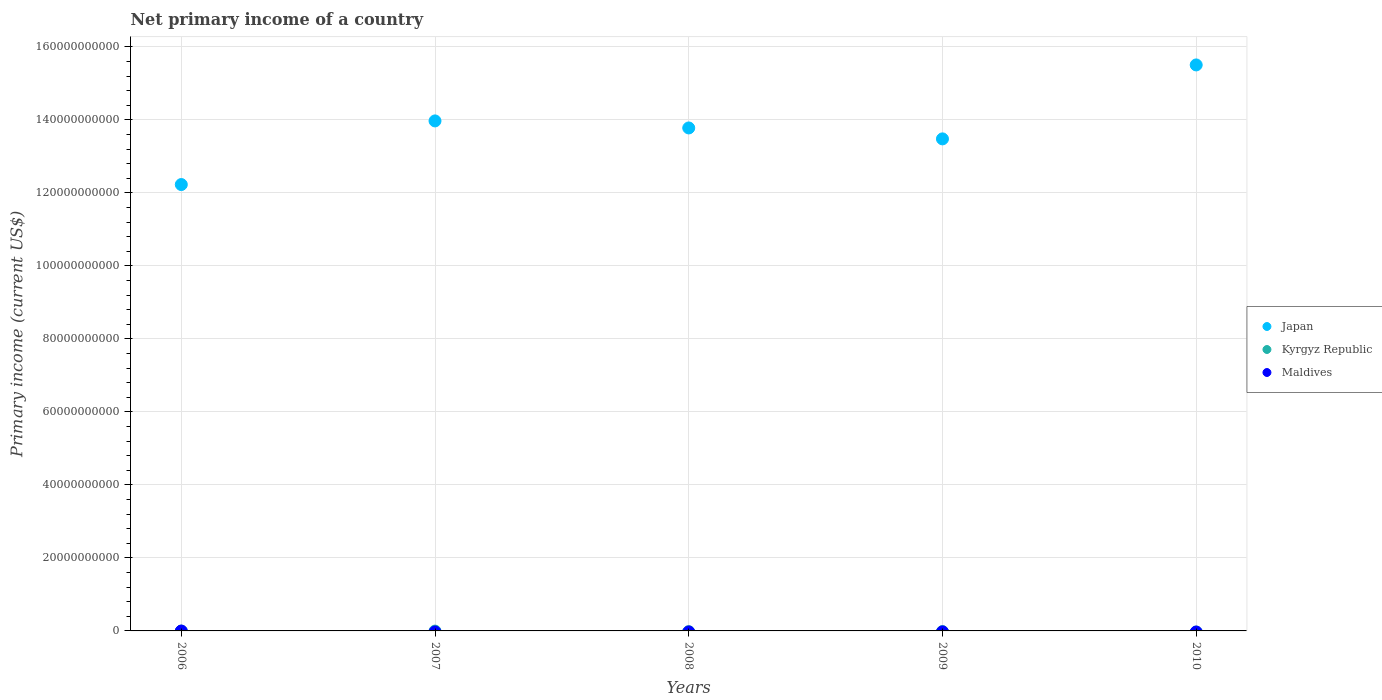Is the number of dotlines equal to the number of legend labels?
Your answer should be very brief. No. Across all years, what is the maximum primary income in Japan?
Ensure brevity in your answer.  1.55e+11. Across all years, what is the minimum primary income in Japan?
Ensure brevity in your answer.  1.22e+11. In which year was the primary income in Japan maximum?
Ensure brevity in your answer.  2010. What is the total primary income in Maldives in the graph?
Offer a terse response. 0. What is the difference between the primary income in Japan in 2008 and that in 2010?
Offer a very short reply. -1.73e+1. What is the difference between the primary income in Kyrgyz Republic in 2006 and the primary income in Japan in 2007?
Your answer should be compact. -1.40e+11. What is the ratio of the primary income in Japan in 2007 to that in 2010?
Ensure brevity in your answer.  0.9. What is the difference between the highest and the second highest primary income in Japan?
Provide a short and direct response. 1.53e+1. What is the difference between the highest and the lowest primary income in Japan?
Provide a succinct answer. 3.28e+1. In how many years, is the primary income in Maldives greater than the average primary income in Maldives taken over all years?
Your answer should be very brief. 0. Does the primary income in Japan monotonically increase over the years?
Keep it short and to the point. No. Is the primary income in Maldives strictly greater than the primary income in Kyrgyz Republic over the years?
Offer a terse response. No. What is the difference between two consecutive major ticks on the Y-axis?
Make the answer very short. 2.00e+1. Does the graph contain any zero values?
Offer a terse response. Yes. Where does the legend appear in the graph?
Provide a succinct answer. Center right. How many legend labels are there?
Provide a succinct answer. 3. How are the legend labels stacked?
Offer a very short reply. Vertical. What is the title of the graph?
Offer a very short reply. Net primary income of a country. Does "Greece" appear as one of the legend labels in the graph?
Provide a succinct answer. No. What is the label or title of the X-axis?
Keep it short and to the point. Years. What is the label or title of the Y-axis?
Make the answer very short. Primary income (current US$). What is the Primary income (current US$) in Japan in 2006?
Your answer should be very brief. 1.22e+11. What is the Primary income (current US$) in Maldives in 2006?
Make the answer very short. 0. What is the Primary income (current US$) of Japan in 2007?
Make the answer very short. 1.40e+11. What is the Primary income (current US$) of Japan in 2008?
Your response must be concise. 1.38e+11. What is the Primary income (current US$) of Kyrgyz Republic in 2008?
Ensure brevity in your answer.  0. What is the Primary income (current US$) in Maldives in 2008?
Give a very brief answer. 0. What is the Primary income (current US$) in Japan in 2009?
Your answer should be compact. 1.35e+11. What is the Primary income (current US$) in Kyrgyz Republic in 2009?
Your response must be concise. 0. What is the Primary income (current US$) of Japan in 2010?
Provide a short and direct response. 1.55e+11. What is the Primary income (current US$) of Maldives in 2010?
Offer a very short reply. 0. Across all years, what is the maximum Primary income (current US$) of Japan?
Your response must be concise. 1.55e+11. Across all years, what is the minimum Primary income (current US$) of Japan?
Ensure brevity in your answer.  1.22e+11. What is the total Primary income (current US$) of Japan in the graph?
Your response must be concise. 6.90e+11. What is the total Primary income (current US$) of Kyrgyz Republic in the graph?
Make the answer very short. 0. What is the difference between the Primary income (current US$) of Japan in 2006 and that in 2007?
Ensure brevity in your answer.  -1.74e+1. What is the difference between the Primary income (current US$) of Japan in 2006 and that in 2008?
Your answer should be compact. -1.55e+1. What is the difference between the Primary income (current US$) in Japan in 2006 and that in 2009?
Provide a succinct answer. -1.25e+1. What is the difference between the Primary income (current US$) of Japan in 2006 and that in 2010?
Provide a short and direct response. -3.28e+1. What is the difference between the Primary income (current US$) of Japan in 2007 and that in 2008?
Keep it short and to the point. 1.93e+09. What is the difference between the Primary income (current US$) of Japan in 2007 and that in 2009?
Offer a very short reply. 4.92e+09. What is the difference between the Primary income (current US$) of Japan in 2007 and that in 2010?
Ensure brevity in your answer.  -1.53e+1. What is the difference between the Primary income (current US$) in Japan in 2008 and that in 2009?
Your answer should be compact. 3.00e+09. What is the difference between the Primary income (current US$) of Japan in 2008 and that in 2010?
Your answer should be compact. -1.73e+1. What is the difference between the Primary income (current US$) of Japan in 2009 and that in 2010?
Give a very brief answer. -2.03e+1. What is the average Primary income (current US$) in Japan per year?
Offer a terse response. 1.38e+11. What is the average Primary income (current US$) of Kyrgyz Republic per year?
Your answer should be very brief. 0. What is the average Primary income (current US$) in Maldives per year?
Your answer should be very brief. 0. What is the ratio of the Primary income (current US$) in Japan in 2006 to that in 2007?
Give a very brief answer. 0.88. What is the ratio of the Primary income (current US$) of Japan in 2006 to that in 2008?
Offer a very short reply. 0.89. What is the ratio of the Primary income (current US$) of Japan in 2006 to that in 2009?
Offer a very short reply. 0.91. What is the ratio of the Primary income (current US$) in Japan in 2006 to that in 2010?
Your answer should be compact. 0.79. What is the ratio of the Primary income (current US$) of Japan in 2007 to that in 2008?
Give a very brief answer. 1.01. What is the ratio of the Primary income (current US$) of Japan in 2007 to that in 2009?
Your answer should be compact. 1.04. What is the ratio of the Primary income (current US$) of Japan in 2007 to that in 2010?
Offer a terse response. 0.9. What is the ratio of the Primary income (current US$) of Japan in 2008 to that in 2009?
Ensure brevity in your answer.  1.02. What is the ratio of the Primary income (current US$) of Japan in 2008 to that in 2010?
Provide a succinct answer. 0.89. What is the ratio of the Primary income (current US$) in Japan in 2009 to that in 2010?
Give a very brief answer. 0.87. What is the difference between the highest and the second highest Primary income (current US$) of Japan?
Your response must be concise. 1.53e+1. What is the difference between the highest and the lowest Primary income (current US$) of Japan?
Make the answer very short. 3.28e+1. 